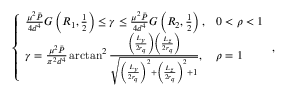Convert formula to latex. <formula><loc_0><loc_0><loc_500><loc_500>\left \{ \begin{array} { l l } { \frac { \mu ^ { 2 } \bar { P } } { 4 d ^ { 4 } } G \left ( R _ { 1 } , \frac { 1 } { 2 } \right ) \leq \gamma \leq \frac { \mu ^ { 2 } \bar { P } } { 4 d ^ { 4 } } G \left ( R _ { 2 } , \frac { 1 } { 2 } \right ) , } & { 0 < \rho < 1 } \\ { \gamma = \frac { \mu ^ { 2 } \bar { P } } { \pi ^ { 2 } d ^ { 4 } } \arctan ^ { 2 } \frac { \left ( \frac { L _ { y } } { 2 r _ { q } } \right ) \left ( \frac { L _ { z } } { 2 r _ { q } } \right ) } { \sqrt { \left ( \frac { L _ { y } } { 2 r _ { q } } \right ) ^ { 2 } + \left ( \frac { L _ { z } } { 2 r _ { q } } \right ) ^ { 2 } + 1 } } , } & { \rho = 1 } \end{array} ,</formula> 